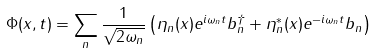Convert formula to latex. <formula><loc_0><loc_0><loc_500><loc_500>\Phi ( x , t ) = \sum _ { n } \frac { 1 } { \sqrt { 2 \omega _ { n } } } \left ( \eta _ { n } ( x ) e ^ { i \omega _ { n } t } b _ { n } ^ { \dagger } + \eta _ { n } ^ { \ast } ( x ) e ^ { - i \omega _ { n } t } b _ { n } \right )</formula> 